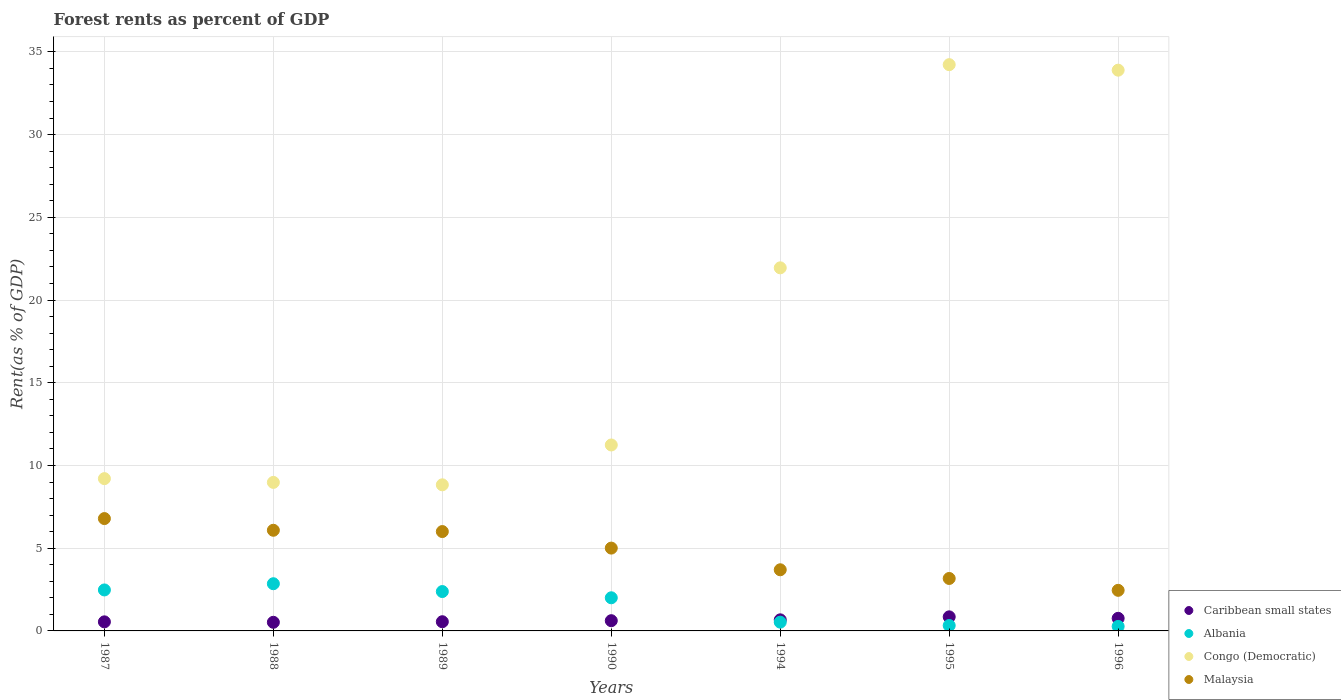How many different coloured dotlines are there?
Make the answer very short. 4. Is the number of dotlines equal to the number of legend labels?
Ensure brevity in your answer.  Yes. What is the forest rent in Congo (Democratic) in 1988?
Provide a succinct answer. 8.98. Across all years, what is the maximum forest rent in Malaysia?
Make the answer very short. 6.79. Across all years, what is the minimum forest rent in Congo (Democratic)?
Offer a very short reply. 8.83. In which year was the forest rent in Congo (Democratic) maximum?
Make the answer very short. 1995. What is the total forest rent in Caribbean small states in the graph?
Make the answer very short. 4.53. What is the difference between the forest rent in Congo (Democratic) in 1988 and that in 1990?
Make the answer very short. -2.26. What is the difference between the forest rent in Congo (Democratic) in 1989 and the forest rent in Caribbean small states in 1987?
Provide a short and direct response. 8.28. What is the average forest rent in Malaysia per year?
Ensure brevity in your answer.  4.74. In the year 1988, what is the difference between the forest rent in Congo (Democratic) and forest rent in Albania?
Provide a short and direct response. 6.12. What is the ratio of the forest rent in Malaysia in 1987 to that in 1996?
Your answer should be compact. 2.77. Is the difference between the forest rent in Congo (Democratic) in 1988 and 1990 greater than the difference between the forest rent in Albania in 1988 and 1990?
Make the answer very short. No. What is the difference between the highest and the second highest forest rent in Malaysia?
Your answer should be compact. 0.71. What is the difference between the highest and the lowest forest rent in Congo (Democratic)?
Keep it short and to the point. 25.39. Is the forest rent in Congo (Democratic) strictly greater than the forest rent in Albania over the years?
Ensure brevity in your answer.  Yes. How many dotlines are there?
Your answer should be compact. 4. What is the difference between two consecutive major ticks on the Y-axis?
Give a very brief answer. 5. Are the values on the major ticks of Y-axis written in scientific E-notation?
Your response must be concise. No. How many legend labels are there?
Ensure brevity in your answer.  4. What is the title of the graph?
Your answer should be very brief. Forest rents as percent of GDP. What is the label or title of the X-axis?
Offer a terse response. Years. What is the label or title of the Y-axis?
Ensure brevity in your answer.  Rent(as % of GDP). What is the Rent(as % of GDP) in Caribbean small states in 1987?
Give a very brief answer. 0.55. What is the Rent(as % of GDP) in Albania in 1987?
Keep it short and to the point. 2.48. What is the Rent(as % of GDP) in Congo (Democratic) in 1987?
Ensure brevity in your answer.  9.2. What is the Rent(as % of GDP) in Malaysia in 1987?
Provide a succinct answer. 6.79. What is the Rent(as % of GDP) of Caribbean small states in 1988?
Provide a succinct answer. 0.52. What is the Rent(as % of GDP) of Albania in 1988?
Ensure brevity in your answer.  2.85. What is the Rent(as % of GDP) of Congo (Democratic) in 1988?
Offer a terse response. 8.98. What is the Rent(as % of GDP) in Malaysia in 1988?
Ensure brevity in your answer.  6.08. What is the Rent(as % of GDP) of Caribbean small states in 1989?
Provide a short and direct response. 0.56. What is the Rent(as % of GDP) in Albania in 1989?
Make the answer very short. 2.38. What is the Rent(as % of GDP) of Congo (Democratic) in 1989?
Offer a terse response. 8.83. What is the Rent(as % of GDP) of Malaysia in 1989?
Make the answer very short. 6.01. What is the Rent(as % of GDP) in Caribbean small states in 1990?
Your response must be concise. 0.62. What is the Rent(as % of GDP) of Albania in 1990?
Offer a very short reply. 2. What is the Rent(as % of GDP) in Congo (Democratic) in 1990?
Your answer should be compact. 11.24. What is the Rent(as % of GDP) of Malaysia in 1990?
Provide a short and direct response. 5.01. What is the Rent(as % of GDP) of Caribbean small states in 1994?
Provide a short and direct response. 0.67. What is the Rent(as % of GDP) in Albania in 1994?
Give a very brief answer. 0.53. What is the Rent(as % of GDP) of Congo (Democratic) in 1994?
Offer a terse response. 21.95. What is the Rent(as % of GDP) of Malaysia in 1994?
Make the answer very short. 3.7. What is the Rent(as % of GDP) of Caribbean small states in 1995?
Provide a short and direct response. 0.85. What is the Rent(as % of GDP) in Albania in 1995?
Ensure brevity in your answer.  0.33. What is the Rent(as % of GDP) in Congo (Democratic) in 1995?
Provide a short and direct response. 34.22. What is the Rent(as % of GDP) of Malaysia in 1995?
Your answer should be compact. 3.17. What is the Rent(as % of GDP) of Caribbean small states in 1996?
Your answer should be compact. 0.76. What is the Rent(as % of GDP) in Albania in 1996?
Provide a short and direct response. 0.27. What is the Rent(as % of GDP) of Congo (Democratic) in 1996?
Offer a terse response. 33.89. What is the Rent(as % of GDP) in Malaysia in 1996?
Offer a terse response. 2.45. Across all years, what is the maximum Rent(as % of GDP) of Caribbean small states?
Make the answer very short. 0.85. Across all years, what is the maximum Rent(as % of GDP) in Albania?
Make the answer very short. 2.85. Across all years, what is the maximum Rent(as % of GDP) in Congo (Democratic)?
Offer a terse response. 34.22. Across all years, what is the maximum Rent(as % of GDP) of Malaysia?
Offer a terse response. 6.79. Across all years, what is the minimum Rent(as % of GDP) in Caribbean small states?
Make the answer very short. 0.52. Across all years, what is the minimum Rent(as % of GDP) in Albania?
Make the answer very short. 0.27. Across all years, what is the minimum Rent(as % of GDP) of Congo (Democratic)?
Offer a terse response. 8.83. Across all years, what is the minimum Rent(as % of GDP) of Malaysia?
Your answer should be compact. 2.45. What is the total Rent(as % of GDP) in Caribbean small states in the graph?
Offer a very short reply. 4.53. What is the total Rent(as % of GDP) in Albania in the graph?
Your answer should be very brief. 10.84. What is the total Rent(as % of GDP) of Congo (Democratic) in the graph?
Your answer should be very brief. 128.31. What is the total Rent(as % of GDP) of Malaysia in the graph?
Keep it short and to the point. 33.2. What is the difference between the Rent(as % of GDP) in Caribbean small states in 1987 and that in 1988?
Make the answer very short. 0.03. What is the difference between the Rent(as % of GDP) in Albania in 1987 and that in 1988?
Give a very brief answer. -0.38. What is the difference between the Rent(as % of GDP) of Congo (Democratic) in 1987 and that in 1988?
Your response must be concise. 0.23. What is the difference between the Rent(as % of GDP) in Malaysia in 1987 and that in 1988?
Provide a succinct answer. 0.71. What is the difference between the Rent(as % of GDP) in Caribbean small states in 1987 and that in 1989?
Ensure brevity in your answer.  -0.01. What is the difference between the Rent(as % of GDP) in Albania in 1987 and that in 1989?
Offer a very short reply. 0.1. What is the difference between the Rent(as % of GDP) of Congo (Democratic) in 1987 and that in 1989?
Provide a short and direct response. 0.37. What is the difference between the Rent(as % of GDP) in Malaysia in 1987 and that in 1989?
Your answer should be compact. 0.78. What is the difference between the Rent(as % of GDP) in Caribbean small states in 1987 and that in 1990?
Your answer should be very brief. -0.07. What is the difference between the Rent(as % of GDP) of Albania in 1987 and that in 1990?
Ensure brevity in your answer.  0.47. What is the difference between the Rent(as % of GDP) in Congo (Democratic) in 1987 and that in 1990?
Provide a short and direct response. -2.03. What is the difference between the Rent(as % of GDP) in Malaysia in 1987 and that in 1990?
Provide a succinct answer. 1.78. What is the difference between the Rent(as % of GDP) of Caribbean small states in 1987 and that in 1994?
Offer a terse response. -0.12. What is the difference between the Rent(as % of GDP) of Albania in 1987 and that in 1994?
Offer a very short reply. 1.95. What is the difference between the Rent(as % of GDP) in Congo (Democratic) in 1987 and that in 1994?
Keep it short and to the point. -12.74. What is the difference between the Rent(as % of GDP) of Malaysia in 1987 and that in 1994?
Provide a short and direct response. 3.09. What is the difference between the Rent(as % of GDP) in Caribbean small states in 1987 and that in 1995?
Your response must be concise. -0.3. What is the difference between the Rent(as % of GDP) of Albania in 1987 and that in 1995?
Your response must be concise. 2.15. What is the difference between the Rent(as % of GDP) in Congo (Democratic) in 1987 and that in 1995?
Your response must be concise. -25.02. What is the difference between the Rent(as % of GDP) of Malaysia in 1987 and that in 1995?
Give a very brief answer. 3.62. What is the difference between the Rent(as % of GDP) of Caribbean small states in 1987 and that in 1996?
Offer a very short reply. -0.21. What is the difference between the Rent(as % of GDP) in Albania in 1987 and that in 1996?
Offer a very short reply. 2.2. What is the difference between the Rent(as % of GDP) in Congo (Democratic) in 1987 and that in 1996?
Ensure brevity in your answer.  -24.69. What is the difference between the Rent(as % of GDP) in Malaysia in 1987 and that in 1996?
Offer a very short reply. 4.34. What is the difference between the Rent(as % of GDP) in Caribbean small states in 1988 and that in 1989?
Keep it short and to the point. -0.03. What is the difference between the Rent(as % of GDP) of Albania in 1988 and that in 1989?
Make the answer very short. 0.47. What is the difference between the Rent(as % of GDP) in Congo (Democratic) in 1988 and that in 1989?
Give a very brief answer. 0.15. What is the difference between the Rent(as % of GDP) in Malaysia in 1988 and that in 1989?
Give a very brief answer. 0.08. What is the difference between the Rent(as % of GDP) in Caribbean small states in 1988 and that in 1990?
Provide a succinct answer. -0.1. What is the difference between the Rent(as % of GDP) of Albania in 1988 and that in 1990?
Your answer should be very brief. 0.85. What is the difference between the Rent(as % of GDP) of Congo (Democratic) in 1988 and that in 1990?
Your answer should be very brief. -2.26. What is the difference between the Rent(as % of GDP) in Malaysia in 1988 and that in 1990?
Provide a succinct answer. 1.08. What is the difference between the Rent(as % of GDP) in Caribbean small states in 1988 and that in 1994?
Offer a terse response. -0.15. What is the difference between the Rent(as % of GDP) in Albania in 1988 and that in 1994?
Give a very brief answer. 2.32. What is the difference between the Rent(as % of GDP) in Congo (Democratic) in 1988 and that in 1994?
Give a very brief answer. -12.97. What is the difference between the Rent(as % of GDP) in Malaysia in 1988 and that in 1994?
Your answer should be compact. 2.39. What is the difference between the Rent(as % of GDP) of Caribbean small states in 1988 and that in 1995?
Ensure brevity in your answer.  -0.33. What is the difference between the Rent(as % of GDP) of Albania in 1988 and that in 1995?
Make the answer very short. 2.53. What is the difference between the Rent(as % of GDP) in Congo (Democratic) in 1988 and that in 1995?
Your response must be concise. -25.25. What is the difference between the Rent(as % of GDP) of Malaysia in 1988 and that in 1995?
Provide a short and direct response. 2.91. What is the difference between the Rent(as % of GDP) of Caribbean small states in 1988 and that in 1996?
Make the answer very short. -0.24. What is the difference between the Rent(as % of GDP) of Albania in 1988 and that in 1996?
Provide a short and direct response. 2.58. What is the difference between the Rent(as % of GDP) in Congo (Democratic) in 1988 and that in 1996?
Give a very brief answer. -24.92. What is the difference between the Rent(as % of GDP) of Malaysia in 1988 and that in 1996?
Give a very brief answer. 3.63. What is the difference between the Rent(as % of GDP) of Caribbean small states in 1989 and that in 1990?
Provide a succinct answer. -0.06. What is the difference between the Rent(as % of GDP) in Albania in 1989 and that in 1990?
Make the answer very short. 0.38. What is the difference between the Rent(as % of GDP) of Congo (Democratic) in 1989 and that in 1990?
Keep it short and to the point. -2.41. What is the difference between the Rent(as % of GDP) in Caribbean small states in 1989 and that in 1994?
Your answer should be compact. -0.11. What is the difference between the Rent(as % of GDP) in Albania in 1989 and that in 1994?
Keep it short and to the point. 1.85. What is the difference between the Rent(as % of GDP) of Congo (Democratic) in 1989 and that in 1994?
Offer a very short reply. -13.11. What is the difference between the Rent(as % of GDP) of Malaysia in 1989 and that in 1994?
Your answer should be very brief. 2.31. What is the difference between the Rent(as % of GDP) in Caribbean small states in 1989 and that in 1995?
Make the answer very short. -0.3. What is the difference between the Rent(as % of GDP) of Albania in 1989 and that in 1995?
Provide a short and direct response. 2.05. What is the difference between the Rent(as % of GDP) of Congo (Democratic) in 1989 and that in 1995?
Your response must be concise. -25.39. What is the difference between the Rent(as % of GDP) in Malaysia in 1989 and that in 1995?
Provide a succinct answer. 2.84. What is the difference between the Rent(as % of GDP) of Caribbean small states in 1989 and that in 1996?
Your answer should be compact. -0.21. What is the difference between the Rent(as % of GDP) in Albania in 1989 and that in 1996?
Give a very brief answer. 2.11. What is the difference between the Rent(as % of GDP) of Congo (Democratic) in 1989 and that in 1996?
Provide a succinct answer. -25.06. What is the difference between the Rent(as % of GDP) of Malaysia in 1989 and that in 1996?
Offer a very short reply. 3.55. What is the difference between the Rent(as % of GDP) of Caribbean small states in 1990 and that in 1994?
Provide a succinct answer. -0.05. What is the difference between the Rent(as % of GDP) of Albania in 1990 and that in 1994?
Your answer should be compact. 1.47. What is the difference between the Rent(as % of GDP) in Congo (Democratic) in 1990 and that in 1994?
Provide a short and direct response. -10.71. What is the difference between the Rent(as % of GDP) of Malaysia in 1990 and that in 1994?
Offer a very short reply. 1.31. What is the difference between the Rent(as % of GDP) of Caribbean small states in 1990 and that in 1995?
Your response must be concise. -0.23. What is the difference between the Rent(as % of GDP) of Albania in 1990 and that in 1995?
Provide a short and direct response. 1.68. What is the difference between the Rent(as % of GDP) of Congo (Democratic) in 1990 and that in 1995?
Offer a very short reply. -22.99. What is the difference between the Rent(as % of GDP) in Malaysia in 1990 and that in 1995?
Offer a very short reply. 1.84. What is the difference between the Rent(as % of GDP) in Caribbean small states in 1990 and that in 1996?
Make the answer very short. -0.14. What is the difference between the Rent(as % of GDP) of Albania in 1990 and that in 1996?
Offer a very short reply. 1.73. What is the difference between the Rent(as % of GDP) of Congo (Democratic) in 1990 and that in 1996?
Provide a short and direct response. -22.65. What is the difference between the Rent(as % of GDP) in Malaysia in 1990 and that in 1996?
Your answer should be compact. 2.55. What is the difference between the Rent(as % of GDP) of Caribbean small states in 1994 and that in 1995?
Make the answer very short. -0.18. What is the difference between the Rent(as % of GDP) of Albania in 1994 and that in 1995?
Your answer should be very brief. 0.2. What is the difference between the Rent(as % of GDP) of Congo (Democratic) in 1994 and that in 1995?
Offer a terse response. -12.28. What is the difference between the Rent(as % of GDP) in Malaysia in 1994 and that in 1995?
Your response must be concise. 0.53. What is the difference between the Rent(as % of GDP) in Caribbean small states in 1994 and that in 1996?
Provide a succinct answer. -0.09. What is the difference between the Rent(as % of GDP) in Albania in 1994 and that in 1996?
Keep it short and to the point. 0.26. What is the difference between the Rent(as % of GDP) in Congo (Democratic) in 1994 and that in 1996?
Make the answer very short. -11.95. What is the difference between the Rent(as % of GDP) of Malaysia in 1994 and that in 1996?
Your answer should be compact. 1.24. What is the difference between the Rent(as % of GDP) in Caribbean small states in 1995 and that in 1996?
Your answer should be very brief. 0.09. What is the difference between the Rent(as % of GDP) of Albania in 1995 and that in 1996?
Offer a terse response. 0.05. What is the difference between the Rent(as % of GDP) of Congo (Democratic) in 1995 and that in 1996?
Provide a succinct answer. 0.33. What is the difference between the Rent(as % of GDP) in Malaysia in 1995 and that in 1996?
Give a very brief answer. 0.72. What is the difference between the Rent(as % of GDP) in Caribbean small states in 1987 and the Rent(as % of GDP) in Albania in 1988?
Your answer should be very brief. -2.3. What is the difference between the Rent(as % of GDP) of Caribbean small states in 1987 and the Rent(as % of GDP) of Congo (Democratic) in 1988?
Offer a very short reply. -8.43. What is the difference between the Rent(as % of GDP) of Caribbean small states in 1987 and the Rent(as % of GDP) of Malaysia in 1988?
Your answer should be very brief. -5.54. What is the difference between the Rent(as % of GDP) in Albania in 1987 and the Rent(as % of GDP) in Congo (Democratic) in 1988?
Ensure brevity in your answer.  -6.5. What is the difference between the Rent(as % of GDP) of Albania in 1987 and the Rent(as % of GDP) of Malaysia in 1988?
Give a very brief answer. -3.61. What is the difference between the Rent(as % of GDP) in Congo (Democratic) in 1987 and the Rent(as % of GDP) in Malaysia in 1988?
Your response must be concise. 3.12. What is the difference between the Rent(as % of GDP) of Caribbean small states in 1987 and the Rent(as % of GDP) of Albania in 1989?
Offer a very short reply. -1.83. What is the difference between the Rent(as % of GDP) in Caribbean small states in 1987 and the Rent(as % of GDP) in Congo (Democratic) in 1989?
Your response must be concise. -8.28. What is the difference between the Rent(as % of GDP) of Caribbean small states in 1987 and the Rent(as % of GDP) of Malaysia in 1989?
Your answer should be compact. -5.46. What is the difference between the Rent(as % of GDP) in Albania in 1987 and the Rent(as % of GDP) in Congo (Democratic) in 1989?
Provide a short and direct response. -6.35. What is the difference between the Rent(as % of GDP) in Albania in 1987 and the Rent(as % of GDP) in Malaysia in 1989?
Offer a terse response. -3.53. What is the difference between the Rent(as % of GDP) in Congo (Democratic) in 1987 and the Rent(as % of GDP) in Malaysia in 1989?
Keep it short and to the point. 3.2. What is the difference between the Rent(as % of GDP) of Caribbean small states in 1987 and the Rent(as % of GDP) of Albania in 1990?
Provide a short and direct response. -1.45. What is the difference between the Rent(as % of GDP) of Caribbean small states in 1987 and the Rent(as % of GDP) of Congo (Democratic) in 1990?
Keep it short and to the point. -10.69. What is the difference between the Rent(as % of GDP) in Caribbean small states in 1987 and the Rent(as % of GDP) in Malaysia in 1990?
Ensure brevity in your answer.  -4.46. What is the difference between the Rent(as % of GDP) of Albania in 1987 and the Rent(as % of GDP) of Congo (Democratic) in 1990?
Provide a short and direct response. -8.76. What is the difference between the Rent(as % of GDP) in Albania in 1987 and the Rent(as % of GDP) in Malaysia in 1990?
Keep it short and to the point. -2.53. What is the difference between the Rent(as % of GDP) of Congo (Democratic) in 1987 and the Rent(as % of GDP) of Malaysia in 1990?
Give a very brief answer. 4.2. What is the difference between the Rent(as % of GDP) of Caribbean small states in 1987 and the Rent(as % of GDP) of Albania in 1994?
Provide a short and direct response. 0.02. What is the difference between the Rent(as % of GDP) in Caribbean small states in 1987 and the Rent(as % of GDP) in Congo (Democratic) in 1994?
Offer a terse response. -21.4. What is the difference between the Rent(as % of GDP) in Caribbean small states in 1987 and the Rent(as % of GDP) in Malaysia in 1994?
Make the answer very short. -3.15. What is the difference between the Rent(as % of GDP) of Albania in 1987 and the Rent(as % of GDP) of Congo (Democratic) in 1994?
Keep it short and to the point. -19.47. What is the difference between the Rent(as % of GDP) of Albania in 1987 and the Rent(as % of GDP) of Malaysia in 1994?
Provide a short and direct response. -1.22. What is the difference between the Rent(as % of GDP) of Congo (Democratic) in 1987 and the Rent(as % of GDP) of Malaysia in 1994?
Give a very brief answer. 5.51. What is the difference between the Rent(as % of GDP) of Caribbean small states in 1987 and the Rent(as % of GDP) of Albania in 1995?
Your response must be concise. 0.22. What is the difference between the Rent(as % of GDP) in Caribbean small states in 1987 and the Rent(as % of GDP) in Congo (Democratic) in 1995?
Give a very brief answer. -33.68. What is the difference between the Rent(as % of GDP) in Caribbean small states in 1987 and the Rent(as % of GDP) in Malaysia in 1995?
Offer a terse response. -2.62. What is the difference between the Rent(as % of GDP) in Albania in 1987 and the Rent(as % of GDP) in Congo (Democratic) in 1995?
Provide a succinct answer. -31.75. What is the difference between the Rent(as % of GDP) of Albania in 1987 and the Rent(as % of GDP) of Malaysia in 1995?
Offer a terse response. -0.69. What is the difference between the Rent(as % of GDP) of Congo (Democratic) in 1987 and the Rent(as % of GDP) of Malaysia in 1995?
Ensure brevity in your answer.  6.03. What is the difference between the Rent(as % of GDP) of Caribbean small states in 1987 and the Rent(as % of GDP) of Albania in 1996?
Keep it short and to the point. 0.28. What is the difference between the Rent(as % of GDP) of Caribbean small states in 1987 and the Rent(as % of GDP) of Congo (Democratic) in 1996?
Your answer should be compact. -33.34. What is the difference between the Rent(as % of GDP) in Caribbean small states in 1987 and the Rent(as % of GDP) in Malaysia in 1996?
Provide a short and direct response. -1.91. What is the difference between the Rent(as % of GDP) of Albania in 1987 and the Rent(as % of GDP) of Congo (Democratic) in 1996?
Provide a succinct answer. -31.42. What is the difference between the Rent(as % of GDP) of Albania in 1987 and the Rent(as % of GDP) of Malaysia in 1996?
Your response must be concise. 0.02. What is the difference between the Rent(as % of GDP) in Congo (Democratic) in 1987 and the Rent(as % of GDP) in Malaysia in 1996?
Your answer should be very brief. 6.75. What is the difference between the Rent(as % of GDP) in Caribbean small states in 1988 and the Rent(as % of GDP) in Albania in 1989?
Make the answer very short. -1.86. What is the difference between the Rent(as % of GDP) in Caribbean small states in 1988 and the Rent(as % of GDP) in Congo (Democratic) in 1989?
Keep it short and to the point. -8.31. What is the difference between the Rent(as % of GDP) of Caribbean small states in 1988 and the Rent(as % of GDP) of Malaysia in 1989?
Provide a short and direct response. -5.48. What is the difference between the Rent(as % of GDP) in Albania in 1988 and the Rent(as % of GDP) in Congo (Democratic) in 1989?
Your response must be concise. -5.98. What is the difference between the Rent(as % of GDP) in Albania in 1988 and the Rent(as % of GDP) in Malaysia in 1989?
Your answer should be compact. -3.15. What is the difference between the Rent(as % of GDP) in Congo (Democratic) in 1988 and the Rent(as % of GDP) in Malaysia in 1989?
Keep it short and to the point. 2.97. What is the difference between the Rent(as % of GDP) in Caribbean small states in 1988 and the Rent(as % of GDP) in Albania in 1990?
Your answer should be compact. -1.48. What is the difference between the Rent(as % of GDP) in Caribbean small states in 1988 and the Rent(as % of GDP) in Congo (Democratic) in 1990?
Provide a short and direct response. -10.72. What is the difference between the Rent(as % of GDP) of Caribbean small states in 1988 and the Rent(as % of GDP) of Malaysia in 1990?
Ensure brevity in your answer.  -4.48. What is the difference between the Rent(as % of GDP) of Albania in 1988 and the Rent(as % of GDP) of Congo (Democratic) in 1990?
Provide a succinct answer. -8.39. What is the difference between the Rent(as % of GDP) of Albania in 1988 and the Rent(as % of GDP) of Malaysia in 1990?
Ensure brevity in your answer.  -2.15. What is the difference between the Rent(as % of GDP) of Congo (Democratic) in 1988 and the Rent(as % of GDP) of Malaysia in 1990?
Provide a succinct answer. 3.97. What is the difference between the Rent(as % of GDP) in Caribbean small states in 1988 and the Rent(as % of GDP) in Albania in 1994?
Provide a short and direct response. -0.01. What is the difference between the Rent(as % of GDP) of Caribbean small states in 1988 and the Rent(as % of GDP) of Congo (Democratic) in 1994?
Make the answer very short. -21.42. What is the difference between the Rent(as % of GDP) in Caribbean small states in 1988 and the Rent(as % of GDP) in Malaysia in 1994?
Keep it short and to the point. -3.17. What is the difference between the Rent(as % of GDP) in Albania in 1988 and the Rent(as % of GDP) in Congo (Democratic) in 1994?
Provide a succinct answer. -19.09. What is the difference between the Rent(as % of GDP) of Albania in 1988 and the Rent(as % of GDP) of Malaysia in 1994?
Give a very brief answer. -0.84. What is the difference between the Rent(as % of GDP) of Congo (Democratic) in 1988 and the Rent(as % of GDP) of Malaysia in 1994?
Offer a terse response. 5.28. What is the difference between the Rent(as % of GDP) of Caribbean small states in 1988 and the Rent(as % of GDP) of Albania in 1995?
Ensure brevity in your answer.  0.19. What is the difference between the Rent(as % of GDP) in Caribbean small states in 1988 and the Rent(as % of GDP) in Congo (Democratic) in 1995?
Make the answer very short. -33.7. What is the difference between the Rent(as % of GDP) of Caribbean small states in 1988 and the Rent(as % of GDP) of Malaysia in 1995?
Provide a succinct answer. -2.65. What is the difference between the Rent(as % of GDP) in Albania in 1988 and the Rent(as % of GDP) in Congo (Democratic) in 1995?
Offer a terse response. -31.37. What is the difference between the Rent(as % of GDP) in Albania in 1988 and the Rent(as % of GDP) in Malaysia in 1995?
Provide a short and direct response. -0.32. What is the difference between the Rent(as % of GDP) in Congo (Democratic) in 1988 and the Rent(as % of GDP) in Malaysia in 1995?
Provide a succinct answer. 5.81. What is the difference between the Rent(as % of GDP) in Caribbean small states in 1988 and the Rent(as % of GDP) in Albania in 1996?
Offer a very short reply. 0.25. What is the difference between the Rent(as % of GDP) in Caribbean small states in 1988 and the Rent(as % of GDP) in Congo (Democratic) in 1996?
Offer a terse response. -33.37. What is the difference between the Rent(as % of GDP) of Caribbean small states in 1988 and the Rent(as % of GDP) of Malaysia in 1996?
Offer a very short reply. -1.93. What is the difference between the Rent(as % of GDP) of Albania in 1988 and the Rent(as % of GDP) of Congo (Democratic) in 1996?
Your response must be concise. -31.04. What is the difference between the Rent(as % of GDP) in Albania in 1988 and the Rent(as % of GDP) in Malaysia in 1996?
Make the answer very short. 0.4. What is the difference between the Rent(as % of GDP) in Congo (Democratic) in 1988 and the Rent(as % of GDP) in Malaysia in 1996?
Provide a short and direct response. 6.52. What is the difference between the Rent(as % of GDP) of Caribbean small states in 1989 and the Rent(as % of GDP) of Albania in 1990?
Provide a short and direct response. -1.45. What is the difference between the Rent(as % of GDP) in Caribbean small states in 1989 and the Rent(as % of GDP) in Congo (Democratic) in 1990?
Your answer should be very brief. -10.68. What is the difference between the Rent(as % of GDP) in Caribbean small states in 1989 and the Rent(as % of GDP) in Malaysia in 1990?
Give a very brief answer. -4.45. What is the difference between the Rent(as % of GDP) in Albania in 1989 and the Rent(as % of GDP) in Congo (Democratic) in 1990?
Give a very brief answer. -8.86. What is the difference between the Rent(as % of GDP) of Albania in 1989 and the Rent(as % of GDP) of Malaysia in 1990?
Your answer should be very brief. -2.63. What is the difference between the Rent(as % of GDP) of Congo (Democratic) in 1989 and the Rent(as % of GDP) of Malaysia in 1990?
Make the answer very short. 3.82. What is the difference between the Rent(as % of GDP) of Caribbean small states in 1989 and the Rent(as % of GDP) of Albania in 1994?
Provide a succinct answer. 0.03. What is the difference between the Rent(as % of GDP) in Caribbean small states in 1989 and the Rent(as % of GDP) in Congo (Democratic) in 1994?
Your response must be concise. -21.39. What is the difference between the Rent(as % of GDP) in Caribbean small states in 1989 and the Rent(as % of GDP) in Malaysia in 1994?
Your answer should be compact. -3.14. What is the difference between the Rent(as % of GDP) of Albania in 1989 and the Rent(as % of GDP) of Congo (Democratic) in 1994?
Your answer should be compact. -19.57. What is the difference between the Rent(as % of GDP) in Albania in 1989 and the Rent(as % of GDP) in Malaysia in 1994?
Ensure brevity in your answer.  -1.32. What is the difference between the Rent(as % of GDP) in Congo (Democratic) in 1989 and the Rent(as % of GDP) in Malaysia in 1994?
Keep it short and to the point. 5.13. What is the difference between the Rent(as % of GDP) of Caribbean small states in 1989 and the Rent(as % of GDP) of Albania in 1995?
Your answer should be compact. 0.23. What is the difference between the Rent(as % of GDP) in Caribbean small states in 1989 and the Rent(as % of GDP) in Congo (Democratic) in 1995?
Your answer should be compact. -33.67. What is the difference between the Rent(as % of GDP) of Caribbean small states in 1989 and the Rent(as % of GDP) of Malaysia in 1995?
Offer a very short reply. -2.61. What is the difference between the Rent(as % of GDP) in Albania in 1989 and the Rent(as % of GDP) in Congo (Democratic) in 1995?
Your answer should be compact. -31.84. What is the difference between the Rent(as % of GDP) in Albania in 1989 and the Rent(as % of GDP) in Malaysia in 1995?
Offer a terse response. -0.79. What is the difference between the Rent(as % of GDP) in Congo (Democratic) in 1989 and the Rent(as % of GDP) in Malaysia in 1995?
Your answer should be compact. 5.66. What is the difference between the Rent(as % of GDP) of Caribbean small states in 1989 and the Rent(as % of GDP) of Albania in 1996?
Give a very brief answer. 0.28. What is the difference between the Rent(as % of GDP) in Caribbean small states in 1989 and the Rent(as % of GDP) in Congo (Democratic) in 1996?
Give a very brief answer. -33.34. What is the difference between the Rent(as % of GDP) in Caribbean small states in 1989 and the Rent(as % of GDP) in Malaysia in 1996?
Your response must be concise. -1.9. What is the difference between the Rent(as % of GDP) in Albania in 1989 and the Rent(as % of GDP) in Congo (Democratic) in 1996?
Offer a very short reply. -31.51. What is the difference between the Rent(as % of GDP) in Albania in 1989 and the Rent(as % of GDP) in Malaysia in 1996?
Give a very brief answer. -0.07. What is the difference between the Rent(as % of GDP) in Congo (Democratic) in 1989 and the Rent(as % of GDP) in Malaysia in 1996?
Make the answer very short. 6.38. What is the difference between the Rent(as % of GDP) of Caribbean small states in 1990 and the Rent(as % of GDP) of Albania in 1994?
Give a very brief answer. 0.09. What is the difference between the Rent(as % of GDP) of Caribbean small states in 1990 and the Rent(as % of GDP) of Congo (Democratic) in 1994?
Offer a terse response. -21.33. What is the difference between the Rent(as % of GDP) in Caribbean small states in 1990 and the Rent(as % of GDP) in Malaysia in 1994?
Offer a terse response. -3.08. What is the difference between the Rent(as % of GDP) in Albania in 1990 and the Rent(as % of GDP) in Congo (Democratic) in 1994?
Ensure brevity in your answer.  -19.94. What is the difference between the Rent(as % of GDP) in Albania in 1990 and the Rent(as % of GDP) in Malaysia in 1994?
Offer a terse response. -1.69. What is the difference between the Rent(as % of GDP) of Congo (Democratic) in 1990 and the Rent(as % of GDP) of Malaysia in 1994?
Offer a terse response. 7.54. What is the difference between the Rent(as % of GDP) in Caribbean small states in 1990 and the Rent(as % of GDP) in Albania in 1995?
Your response must be concise. 0.29. What is the difference between the Rent(as % of GDP) of Caribbean small states in 1990 and the Rent(as % of GDP) of Congo (Democratic) in 1995?
Your answer should be very brief. -33.61. What is the difference between the Rent(as % of GDP) in Caribbean small states in 1990 and the Rent(as % of GDP) in Malaysia in 1995?
Provide a short and direct response. -2.55. What is the difference between the Rent(as % of GDP) in Albania in 1990 and the Rent(as % of GDP) in Congo (Democratic) in 1995?
Offer a terse response. -32.22. What is the difference between the Rent(as % of GDP) of Albania in 1990 and the Rent(as % of GDP) of Malaysia in 1995?
Your answer should be very brief. -1.17. What is the difference between the Rent(as % of GDP) in Congo (Democratic) in 1990 and the Rent(as % of GDP) in Malaysia in 1995?
Make the answer very short. 8.07. What is the difference between the Rent(as % of GDP) in Caribbean small states in 1990 and the Rent(as % of GDP) in Albania in 1996?
Your answer should be very brief. 0.35. What is the difference between the Rent(as % of GDP) in Caribbean small states in 1990 and the Rent(as % of GDP) in Congo (Democratic) in 1996?
Provide a succinct answer. -33.27. What is the difference between the Rent(as % of GDP) in Caribbean small states in 1990 and the Rent(as % of GDP) in Malaysia in 1996?
Provide a succinct answer. -1.84. What is the difference between the Rent(as % of GDP) of Albania in 1990 and the Rent(as % of GDP) of Congo (Democratic) in 1996?
Ensure brevity in your answer.  -31.89. What is the difference between the Rent(as % of GDP) of Albania in 1990 and the Rent(as % of GDP) of Malaysia in 1996?
Make the answer very short. -0.45. What is the difference between the Rent(as % of GDP) in Congo (Democratic) in 1990 and the Rent(as % of GDP) in Malaysia in 1996?
Keep it short and to the point. 8.79. What is the difference between the Rent(as % of GDP) in Caribbean small states in 1994 and the Rent(as % of GDP) in Albania in 1995?
Offer a very short reply. 0.34. What is the difference between the Rent(as % of GDP) of Caribbean small states in 1994 and the Rent(as % of GDP) of Congo (Democratic) in 1995?
Make the answer very short. -33.55. What is the difference between the Rent(as % of GDP) of Caribbean small states in 1994 and the Rent(as % of GDP) of Malaysia in 1995?
Your answer should be compact. -2.5. What is the difference between the Rent(as % of GDP) of Albania in 1994 and the Rent(as % of GDP) of Congo (Democratic) in 1995?
Offer a terse response. -33.69. What is the difference between the Rent(as % of GDP) of Albania in 1994 and the Rent(as % of GDP) of Malaysia in 1995?
Keep it short and to the point. -2.64. What is the difference between the Rent(as % of GDP) in Congo (Democratic) in 1994 and the Rent(as % of GDP) in Malaysia in 1995?
Provide a succinct answer. 18.78. What is the difference between the Rent(as % of GDP) of Caribbean small states in 1994 and the Rent(as % of GDP) of Albania in 1996?
Provide a short and direct response. 0.4. What is the difference between the Rent(as % of GDP) in Caribbean small states in 1994 and the Rent(as % of GDP) in Congo (Democratic) in 1996?
Provide a short and direct response. -33.22. What is the difference between the Rent(as % of GDP) in Caribbean small states in 1994 and the Rent(as % of GDP) in Malaysia in 1996?
Offer a terse response. -1.78. What is the difference between the Rent(as % of GDP) of Albania in 1994 and the Rent(as % of GDP) of Congo (Democratic) in 1996?
Your answer should be very brief. -33.36. What is the difference between the Rent(as % of GDP) in Albania in 1994 and the Rent(as % of GDP) in Malaysia in 1996?
Your answer should be very brief. -1.92. What is the difference between the Rent(as % of GDP) in Congo (Democratic) in 1994 and the Rent(as % of GDP) in Malaysia in 1996?
Offer a very short reply. 19.49. What is the difference between the Rent(as % of GDP) in Caribbean small states in 1995 and the Rent(as % of GDP) in Albania in 1996?
Your answer should be compact. 0.58. What is the difference between the Rent(as % of GDP) in Caribbean small states in 1995 and the Rent(as % of GDP) in Congo (Democratic) in 1996?
Your response must be concise. -33.04. What is the difference between the Rent(as % of GDP) of Caribbean small states in 1995 and the Rent(as % of GDP) of Malaysia in 1996?
Make the answer very short. -1.6. What is the difference between the Rent(as % of GDP) of Albania in 1995 and the Rent(as % of GDP) of Congo (Democratic) in 1996?
Make the answer very short. -33.56. What is the difference between the Rent(as % of GDP) of Albania in 1995 and the Rent(as % of GDP) of Malaysia in 1996?
Provide a succinct answer. -2.13. What is the difference between the Rent(as % of GDP) of Congo (Democratic) in 1995 and the Rent(as % of GDP) of Malaysia in 1996?
Provide a short and direct response. 31.77. What is the average Rent(as % of GDP) in Caribbean small states per year?
Your answer should be very brief. 0.65. What is the average Rent(as % of GDP) in Albania per year?
Your answer should be compact. 1.55. What is the average Rent(as % of GDP) in Congo (Democratic) per year?
Ensure brevity in your answer.  18.33. What is the average Rent(as % of GDP) of Malaysia per year?
Provide a succinct answer. 4.74. In the year 1987, what is the difference between the Rent(as % of GDP) in Caribbean small states and Rent(as % of GDP) in Albania?
Provide a short and direct response. -1.93. In the year 1987, what is the difference between the Rent(as % of GDP) in Caribbean small states and Rent(as % of GDP) in Congo (Democratic)?
Offer a terse response. -8.66. In the year 1987, what is the difference between the Rent(as % of GDP) of Caribbean small states and Rent(as % of GDP) of Malaysia?
Provide a short and direct response. -6.24. In the year 1987, what is the difference between the Rent(as % of GDP) of Albania and Rent(as % of GDP) of Congo (Democratic)?
Make the answer very short. -6.73. In the year 1987, what is the difference between the Rent(as % of GDP) of Albania and Rent(as % of GDP) of Malaysia?
Ensure brevity in your answer.  -4.31. In the year 1987, what is the difference between the Rent(as % of GDP) in Congo (Democratic) and Rent(as % of GDP) in Malaysia?
Your answer should be compact. 2.41. In the year 1988, what is the difference between the Rent(as % of GDP) of Caribbean small states and Rent(as % of GDP) of Albania?
Provide a short and direct response. -2.33. In the year 1988, what is the difference between the Rent(as % of GDP) of Caribbean small states and Rent(as % of GDP) of Congo (Democratic)?
Keep it short and to the point. -8.46. In the year 1988, what is the difference between the Rent(as % of GDP) of Caribbean small states and Rent(as % of GDP) of Malaysia?
Ensure brevity in your answer.  -5.56. In the year 1988, what is the difference between the Rent(as % of GDP) in Albania and Rent(as % of GDP) in Congo (Democratic)?
Offer a very short reply. -6.12. In the year 1988, what is the difference between the Rent(as % of GDP) of Albania and Rent(as % of GDP) of Malaysia?
Make the answer very short. -3.23. In the year 1988, what is the difference between the Rent(as % of GDP) of Congo (Democratic) and Rent(as % of GDP) of Malaysia?
Ensure brevity in your answer.  2.89. In the year 1989, what is the difference between the Rent(as % of GDP) in Caribbean small states and Rent(as % of GDP) in Albania?
Your response must be concise. -1.82. In the year 1989, what is the difference between the Rent(as % of GDP) of Caribbean small states and Rent(as % of GDP) of Congo (Democratic)?
Provide a succinct answer. -8.28. In the year 1989, what is the difference between the Rent(as % of GDP) in Caribbean small states and Rent(as % of GDP) in Malaysia?
Your answer should be very brief. -5.45. In the year 1989, what is the difference between the Rent(as % of GDP) in Albania and Rent(as % of GDP) in Congo (Democratic)?
Your answer should be compact. -6.45. In the year 1989, what is the difference between the Rent(as % of GDP) in Albania and Rent(as % of GDP) in Malaysia?
Make the answer very short. -3.63. In the year 1989, what is the difference between the Rent(as % of GDP) in Congo (Democratic) and Rent(as % of GDP) in Malaysia?
Offer a very short reply. 2.83. In the year 1990, what is the difference between the Rent(as % of GDP) in Caribbean small states and Rent(as % of GDP) in Albania?
Provide a short and direct response. -1.38. In the year 1990, what is the difference between the Rent(as % of GDP) in Caribbean small states and Rent(as % of GDP) in Congo (Democratic)?
Make the answer very short. -10.62. In the year 1990, what is the difference between the Rent(as % of GDP) in Caribbean small states and Rent(as % of GDP) in Malaysia?
Give a very brief answer. -4.39. In the year 1990, what is the difference between the Rent(as % of GDP) of Albania and Rent(as % of GDP) of Congo (Democratic)?
Your answer should be very brief. -9.24. In the year 1990, what is the difference between the Rent(as % of GDP) in Albania and Rent(as % of GDP) in Malaysia?
Your answer should be very brief. -3. In the year 1990, what is the difference between the Rent(as % of GDP) in Congo (Democratic) and Rent(as % of GDP) in Malaysia?
Make the answer very short. 6.23. In the year 1994, what is the difference between the Rent(as % of GDP) in Caribbean small states and Rent(as % of GDP) in Albania?
Give a very brief answer. 0.14. In the year 1994, what is the difference between the Rent(as % of GDP) in Caribbean small states and Rent(as % of GDP) in Congo (Democratic)?
Make the answer very short. -21.27. In the year 1994, what is the difference between the Rent(as % of GDP) in Caribbean small states and Rent(as % of GDP) in Malaysia?
Make the answer very short. -3.03. In the year 1994, what is the difference between the Rent(as % of GDP) of Albania and Rent(as % of GDP) of Congo (Democratic)?
Give a very brief answer. -21.42. In the year 1994, what is the difference between the Rent(as % of GDP) of Albania and Rent(as % of GDP) of Malaysia?
Provide a short and direct response. -3.17. In the year 1994, what is the difference between the Rent(as % of GDP) of Congo (Democratic) and Rent(as % of GDP) of Malaysia?
Offer a terse response. 18.25. In the year 1995, what is the difference between the Rent(as % of GDP) of Caribbean small states and Rent(as % of GDP) of Albania?
Give a very brief answer. 0.52. In the year 1995, what is the difference between the Rent(as % of GDP) of Caribbean small states and Rent(as % of GDP) of Congo (Democratic)?
Offer a terse response. -33.37. In the year 1995, what is the difference between the Rent(as % of GDP) of Caribbean small states and Rent(as % of GDP) of Malaysia?
Your response must be concise. -2.32. In the year 1995, what is the difference between the Rent(as % of GDP) of Albania and Rent(as % of GDP) of Congo (Democratic)?
Make the answer very short. -33.9. In the year 1995, what is the difference between the Rent(as % of GDP) in Albania and Rent(as % of GDP) in Malaysia?
Ensure brevity in your answer.  -2.84. In the year 1995, what is the difference between the Rent(as % of GDP) of Congo (Democratic) and Rent(as % of GDP) of Malaysia?
Your response must be concise. 31.05. In the year 1996, what is the difference between the Rent(as % of GDP) of Caribbean small states and Rent(as % of GDP) of Albania?
Your response must be concise. 0.49. In the year 1996, what is the difference between the Rent(as % of GDP) in Caribbean small states and Rent(as % of GDP) in Congo (Democratic)?
Your answer should be compact. -33.13. In the year 1996, what is the difference between the Rent(as % of GDP) of Caribbean small states and Rent(as % of GDP) of Malaysia?
Your answer should be compact. -1.69. In the year 1996, what is the difference between the Rent(as % of GDP) in Albania and Rent(as % of GDP) in Congo (Democratic)?
Make the answer very short. -33.62. In the year 1996, what is the difference between the Rent(as % of GDP) in Albania and Rent(as % of GDP) in Malaysia?
Give a very brief answer. -2.18. In the year 1996, what is the difference between the Rent(as % of GDP) of Congo (Democratic) and Rent(as % of GDP) of Malaysia?
Provide a succinct answer. 31.44. What is the ratio of the Rent(as % of GDP) of Caribbean small states in 1987 to that in 1988?
Ensure brevity in your answer.  1.05. What is the ratio of the Rent(as % of GDP) of Albania in 1987 to that in 1988?
Provide a succinct answer. 0.87. What is the ratio of the Rent(as % of GDP) in Congo (Democratic) in 1987 to that in 1988?
Your answer should be very brief. 1.03. What is the ratio of the Rent(as % of GDP) of Malaysia in 1987 to that in 1988?
Offer a very short reply. 1.12. What is the ratio of the Rent(as % of GDP) of Caribbean small states in 1987 to that in 1989?
Ensure brevity in your answer.  0.99. What is the ratio of the Rent(as % of GDP) of Albania in 1987 to that in 1989?
Your response must be concise. 1.04. What is the ratio of the Rent(as % of GDP) in Congo (Democratic) in 1987 to that in 1989?
Provide a succinct answer. 1.04. What is the ratio of the Rent(as % of GDP) of Malaysia in 1987 to that in 1989?
Keep it short and to the point. 1.13. What is the ratio of the Rent(as % of GDP) of Caribbean small states in 1987 to that in 1990?
Offer a very short reply. 0.89. What is the ratio of the Rent(as % of GDP) of Albania in 1987 to that in 1990?
Offer a very short reply. 1.24. What is the ratio of the Rent(as % of GDP) in Congo (Democratic) in 1987 to that in 1990?
Your answer should be compact. 0.82. What is the ratio of the Rent(as % of GDP) of Malaysia in 1987 to that in 1990?
Ensure brevity in your answer.  1.36. What is the ratio of the Rent(as % of GDP) in Caribbean small states in 1987 to that in 1994?
Offer a very short reply. 0.82. What is the ratio of the Rent(as % of GDP) in Albania in 1987 to that in 1994?
Keep it short and to the point. 4.67. What is the ratio of the Rent(as % of GDP) of Congo (Democratic) in 1987 to that in 1994?
Your response must be concise. 0.42. What is the ratio of the Rent(as % of GDP) in Malaysia in 1987 to that in 1994?
Keep it short and to the point. 1.84. What is the ratio of the Rent(as % of GDP) in Caribbean small states in 1987 to that in 1995?
Offer a very short reply. 0.64. What is the ratio of the Rent(as % of GDP) of Albania in 1987 to that in 1995?
Make the answer very short. 7.57. What is the ratio of the Rent(as % of GDP) in Congo (Democratic) in 1987 to that in 1995?
Provide a succinct answer. 0.27. What is the ratio of the Rent(as % of GDP) in Malaysia in 1987 to that in 1995?
Offer a terse response. 2.14. What is the ratio of the Rent(as % of GDP) of Caribbean small states in 1987 to that in 1996?
Your response must be concise. 0.72. What is the ratio of the Rent(as % of GDP) in Albania in 1987 to that in 1996?
Your answer should be very brief. 9.08. What is the ratio of the Rent(as % of GDP) in Congo (Democratic) in 1987 to that in 1996?
Provide a short and direct response. 0.27. What is the ratio of the Rent(as % of GDP) of Malaysia in 1987 to that in 1996?
Your answer should be compact. 2.77. What is the ratio of the Rent(as % of GDP) of Caribbean small states in 1988 to that in 1989?
Make the answer very short. 0.94. What is the ratio of the Rent(as % of GDP) of Albania in 1988 to that in 1989?
Give a very brief answer. 1.2. What is the ratio of the Rent(as % of GDP) of Congo (Democratic) in 1988 to that in 1989?
Your answer should be very brief. 1.02. What is the ratio of the Rent(as % of GDP) of Caribbean small states in 1988 to that in 1990?
Your answer should be very brief. 0.84. What is the ratio of the Rent(as % of GDP) of Albania in 1988 to that in 1990?
Keep it short and to the point. 1.42. What is the ratio of the Rent(as % of GDP) in Congo (Democratic) in 1988 to that in 1990?
Provide a succinct answer. 0.8. What is the ratio of the Rent(as % of GDP) of Malaysia in 1988 to that in 1990?
Offer a terse response. 1.22. What is the ratio of the Rent(as % of GDP) of Caribbean small states in 1988 to that in 1994?
Offer a terse response. 0.78. What is the ratio of the Rent(as % of GDP) of Albania in 1988 to that in 1994?
Ensure brevity in your answer.  5.38. What is the ratio of the Rent(as % of GDP) in Congo (Democratic) in 1988 to that in 1994?
Give a very brief answer. 0.41. What is the ratio of the Rent(as % of GDP) of Malaysia in 1988 to that in 1994?
Provide a succinct answer. 1.65. What is the ratio of the Rent(as % of GDP) of Caribbean small states in 1988 to that in 1995?
Offer a terse response. 0.61. What is the ratio of the Rent(as % of GDP) in Albania in 1988 to that in 1995?
Offer a terse response. 8.72. What is the ratio of the Rent(as % of GDP) of Congo (Democratic) in 1988 to that in 1995?
Provide a succinct answer. 0.26. What is the ratio of the Rent(as % of GDP) of Malaysia in 1988 to that in 1995?
Provide a succinct answer. 1.92. What is the ratio of the Rent(as % of GDP) of Caribbean small states in 1988 to that in 1996?
Your answer should be very brief. 0.68. What is the ratio of the Rent(as % of GDP) in Albania in 1988 to that in 1996?
Provide a short and direct response. 10.46. What is the ratio of the Rent(as % of GDP) in Congo (Democratic) in 1988 to that in 1996?
Make the answer very short. 0.26. What is the ratio of the Rent(as % of GDP) in Malaysia in 1988 to that in 1996?
Offer a very short reply. 2.48. What is the ratio of the Rent(as % of GDP) in Caribbean small states in 1989 to that in 1990?
Ensure brevity in your answer.  0.9. What is the ratio of the Rent(as % of GDP) in Albania in 1989 to that in 1990?
Offer a very short reply. 1.19. What is the ratio of the Rent(as % of GDP) of Congo (Democratic) in 1989 to that in 1990?
Provide a short and direct response. 0.79. What is the ratio of the Rent(as % of GDP) in Malaysia in 1989 to that in 1990?
Keep it short and to the point. 1.2. What is the ratio of the Rent(as % of GDP) in Caribbean small states in 1989 to that in 1994?
Offer a terse response. 0.83. What is the ratio of the Rent(as % of GDP) in Albania in 1989 to that in 1994?
Offer a terse response. 4.49. What is the ratio of the Rent(as % of GDP) in Congo (Democratic) in 1989 to that in 1994?
Provide a succinct answer. 0.4. What is the ratio of the Rent(as % of GDP) in Malaysia in 1989 to that in 1994?
Make the answer very short. 1.62. What is the ratio of the Rent(as % of GDP) in Caribbean small states in 1989 to that in 1995?
Provide a succinct answer. 0.65. What is the ratio of the Rent(as % of GDP) in Albania in 1989 to that in 1995?
Your answer should be compact. 7.27. What is the ratio of the Rent(as % of GDP) of Congo (Democratic) in 1989 to that in 1995?
Give a very brief answer. 0.26. What is the ratio of the Rent(as % of GDP) in Malaysia in 1989 to that in 1995?
Offer a very short reply. 1.89. What is the ratio of the Rent(as % of GDP) in Caribbean small states in 1989 to that in 1996?
Give a very brief answer. 0.73. What is the ratio of the Rent(as % of GDP) in Albania in 1989 to that in 1996?
Make the answer very short. 8.73. What is the ratio of the Rent(as % of GDP) of Congo (Democratic) in 1989 to that in 1996?
Your response must be concise. 0.26. What is the ratio of the Rent(as % of GDP) of Malaysia in 1989 to that in 1996?
Provide a succinct answer. 2.45. What is the ratio of the Rent(as % of GDP) in Caribbean small states in 1990 to that in 1994?
Ensure brevity in your answer.  0.92. What is the ratio of the Rent(as % of GDP) of Albania in 1990 to that in 1994?
Your answer should be compact. 3.78. What is the ratio of the Rent(as % of GDP) in Congo (Democratic) in 1990 to that in 1994?
Make the answer very short. 0.51. What is the ratio of the Rent(as % of GDP) in Malaysia in 1990 to that in 1994?
Offer a very short reply. 1.35. What is the ratio of the Rent(as % of GDP) in Caribbean small states in 1990 to that in 1995?
Offer a very short reply. 0.73. What is the ratio of the Rent(as % of GDP) of Albania in 1990 to that in 1995?
Keep it short and to the point. 6.12. What is the ratio of the Rent(as % of GDP) in Congo (Democratic) in 1990 to that in 1995?
Make the answer very short. 0.33. What is the ratio of the Rent(as % of GDP) of Malaysia in 1990 to that in 1995?
Keep it short and to the point. 1.58. What is the ratio of the Rent(as % of GDP) in Caribbean small states in 1990 to that in 1996?
Provide a succinct answer. 0.81. What is the ratio of the Rent(as % of GDP) of Albania in 1990 to that in 1996?
Your answer should be compact. 7.34. What is the ratio of the Rent(as % of GDP) in Congo (Democratic) in 1990 to that in 1996?
Your answer should be compact. 0.33. What is the ratio of the Rent(as % of GDP) of Malaysia in 1990 to that in 1996?
Give a very brief answer. 2.04. What is the ratio of the Rent(as % of GDP) in Caribbean small states in 1994 to that in 1995?
Provide a short and direct response. 0.79. What is the ratio of the Rent(as % of GDP) in Albania in 1994 to that in 1995?
Provide a short and direct response. 1.62. What is the ratio of the Rent(as % of GDP) of Congo (Democratic) in 1994 to that in 1995?
Your answer should be compact. 0.64. What is the ratio of the Rent(as % of GDP) in Malaysia in 1994 to that in 1995?
Your answer should be compact. 1.17. What is the ratio of the Rent(as % of GDP) in Caribbean small states in 1994 to that in 1996?
Keep it short and to the point. 0.88. What is the ratio of the Rent(as % of GDP) of Albania in 1994 to that in 1996?
Provide a succinct answer. 1.94. What is the ratio of the Rent(as % of GDP) in Congo (Democratic) in 1994 to that in 1996?
Ensure brevity in your answer.  0.65. What is the ratio of the Rent(as % of GDP) in Malaysia in 1994 to that in 1996?
Make the answer very short. 1.51. What is the ratio of the Rent(as % of GDP) of Caribbean small states in 1995 to that in 1996?
Your response must be concise. 1.12. What is the ratio of the Rent(as % of GDP) of Albania in 1995 to that in 1996?
Make the answer very short. 1.2. What is the ratio of the Rent(as % of GDP) of Congo (Democratic) in 1995 to that in 1996?
Your response must be concise. 1.01. What is the ratio of the Rent(as % of GDP) of Malaysia in 1995 to that in 1996?
Your answer should be very brief. 1.29. What is the difference between the highest and the second highest Rent(as % of GDP) in Caribbean small states?
Keep it short and to the point. 0.09. What is the difference between the highest and the second highest Rent(as % of GDP) in Albania?
Give a very brief answer. 0.38. What is the difference between the highest and the second highest Rent(as % of GDP) in Congo (Democratic)?
Offer a terse response. 0.33. What is the difference between the highest and the second highest Rent(as % of GDP) of Malaysia?
Your answer should be very brief. 0.71. What is the difference between the highest and the lowest Rent(as % of GDP) of Caribbean small states?
Make the answer very short. 0.33. What is the difference between the highest and the lowest Rent(as % of GDP) of Albania?
Offer a very short reply. 2.58. What is the difference between the highest and the lowest Rent(as % of GDP) in Congo (Democratic)?
Provide a succinct answer. 25.39. What is the difference between the highest and the lowest Rent(as % of GDP) of Malaysia?
Provide a short and direct response. 4.34. 